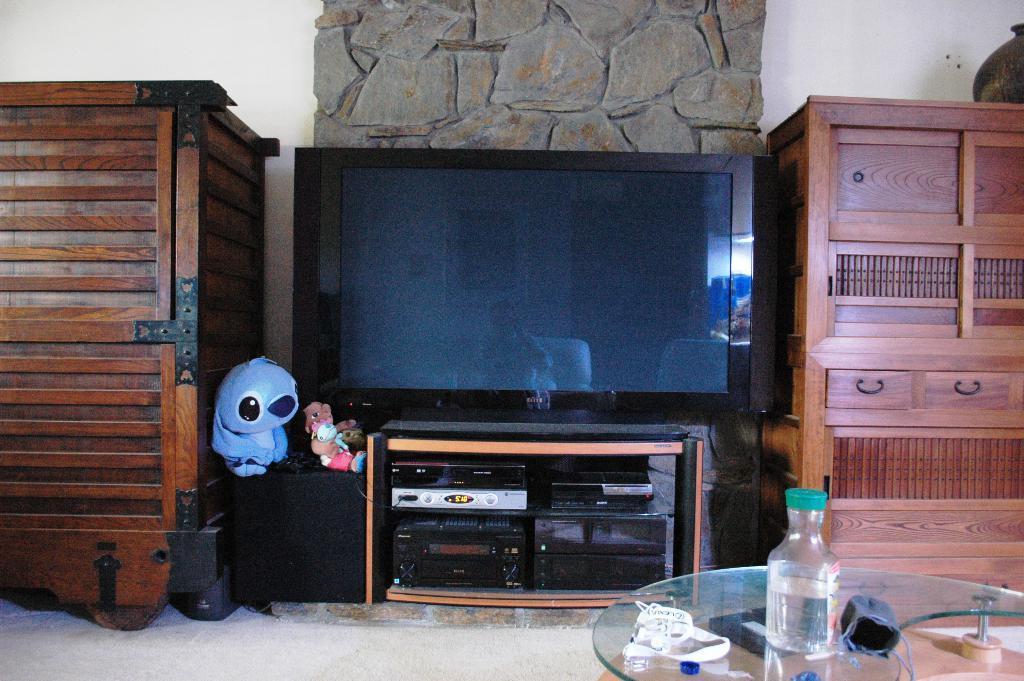Describe this image in one or two sentences. As we can see in the image there is a white color wall, rock, television, a table. On table there is a bottle. 